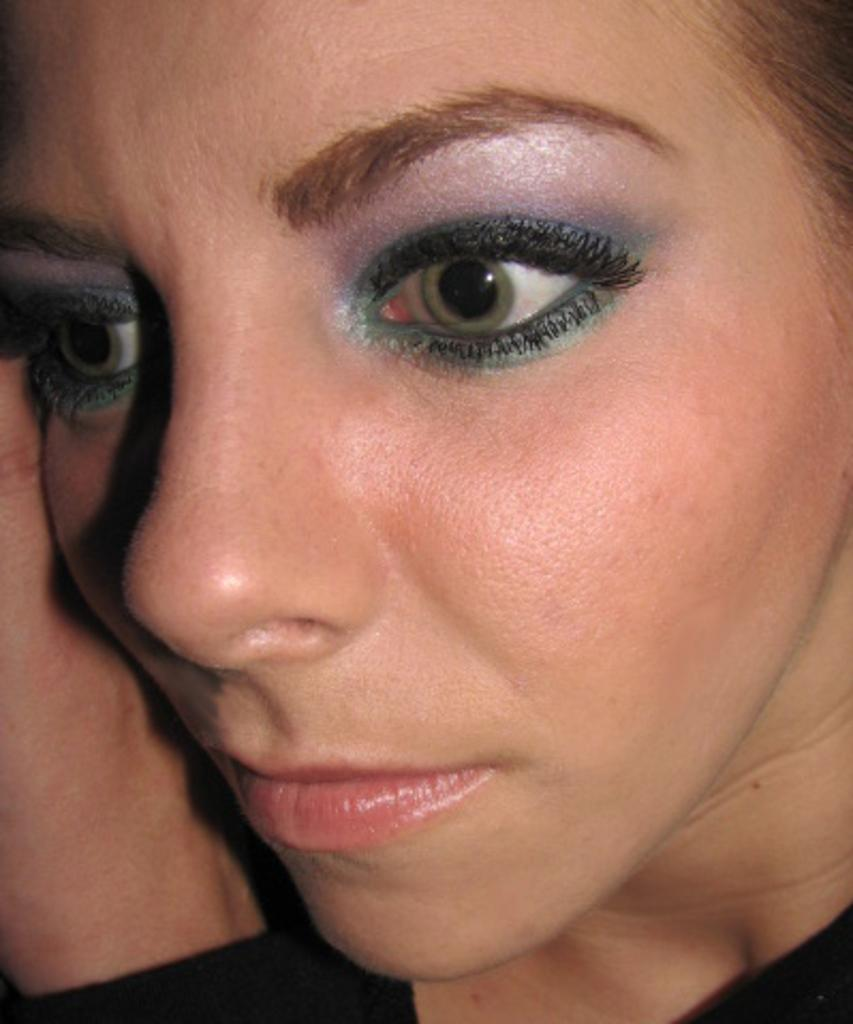What is the main subject of the image? The main subject of the image is the face of a woman. How many ants can be seen crawling on the woman's face in the image? There are no ants present on the woman's face in the image. Who is the owner of the woman's face in the image? The image is a photograph or illustration, so it does not have an owner in the traditional sense. 